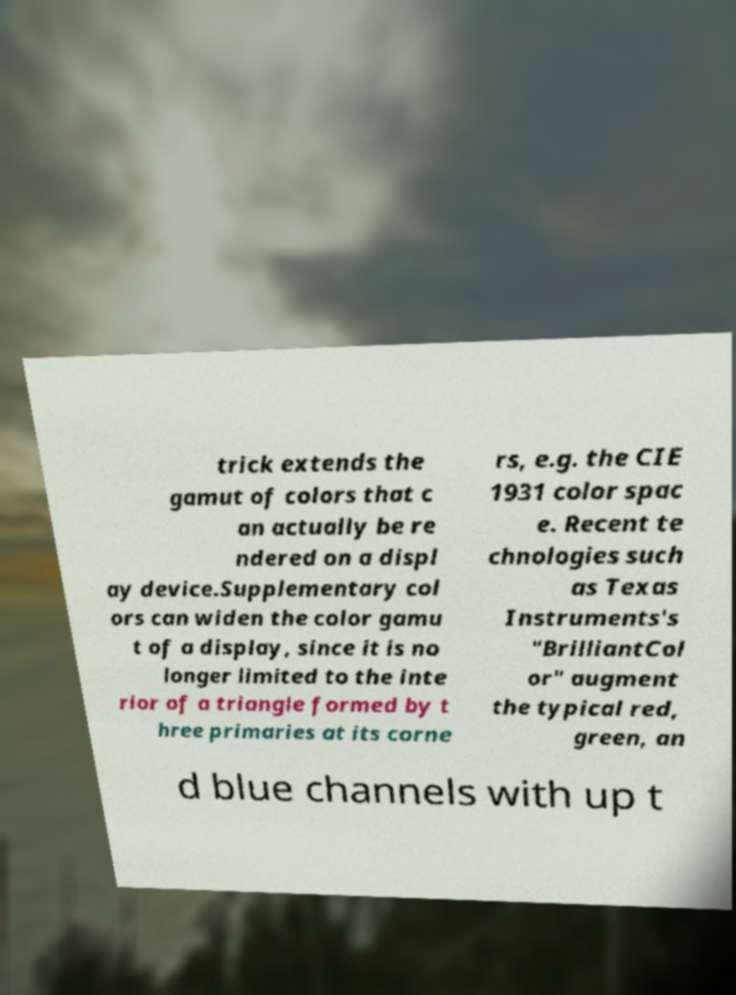Please identify and transcribe the text found in this image. trick extends the gamut of colors that c an actually be re ndered on a displ ay device.Supplementary col ors can widen the color gamu t of a display, since it is no longer limited to the inte rior of a triangle formed by t hree primaries at its corne rs, e.g. the CIE 1931 color spac e. Recent te chnologies such as Texas Instruments's "BrilliantCol or" augment the typical red, green, an d blue channels with up t 